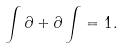Convert formula to latex. <formula><loc_0><loc_0><loc_500><loc_500>\int \partial + \partial \int = 1 .</formula> 